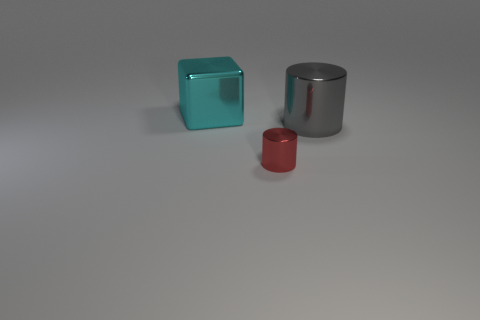What is the size of the cyan object that is made of the same material as the tiny red cylinder? The cyan object is considerably larger in size compared to both the tiny red cylinder and the silver cylinder. It appears to be a cube with approximately equal dimensions on all sides, signifying a sizable volume relative to the other objects present. 